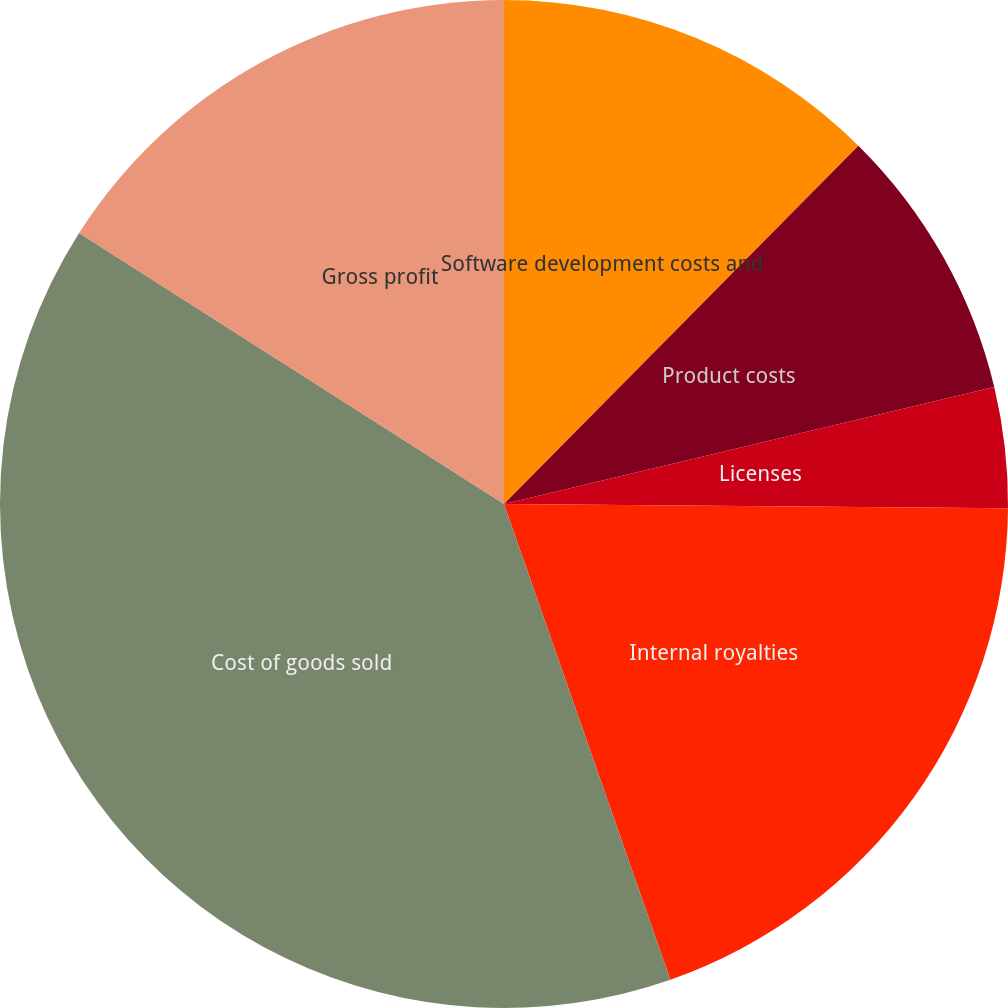Convert chart. <chart><loc_0><loc_0><loc_500><loc_500><pie_chart><fcel>Software development costs and<fcel>Product costs<fcel>Licenses<fcel>Internal royalties<fcel>Cost of goods sold<fcel>Gross profit<nl><fcel>12.41%<fcel>8.86%<fcel>3.86%<fcel>19.51%<fcel>39.39%<fcel>15.96%<nl></chart> 